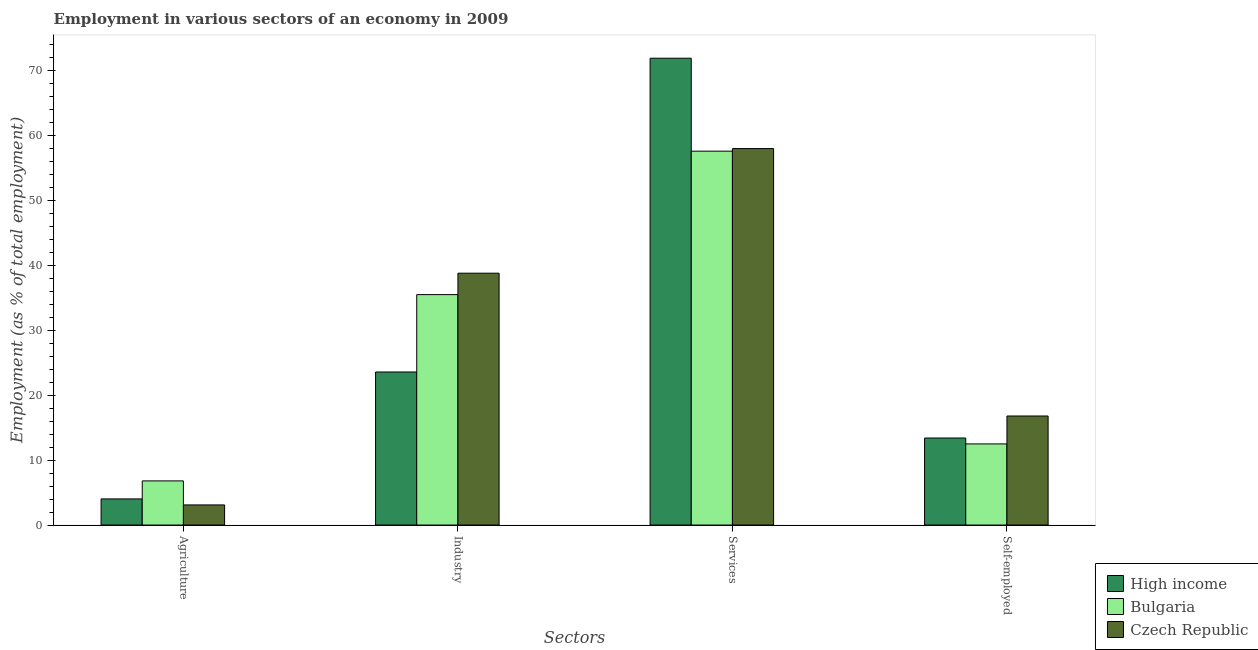How many different coloured bars are there?
Give a very brief answer. 3. How many bars are there on the 2nd tick from the left?
Keep it short and to the point. 3. How many bars are there on the 1st tick from the right?
Keep it short and to the point. 3. What is the label of the 1st group of bars from the left?
Offer a very short reply. Agriculture. What is the percentage of workers in agriculture in Czech Republic?
Offer a terse response. 3.1. Across all countries, what is the maximum percentage of workers in services?
Give a very brief answer. 71.92. Across all countries, what is the minimum percentage of workers in services?
Your answer should be very brief. 57.6. In which country was the percentage of workers in services maximum?
Make the answer very short. High income. In which country was the percentage of workers in industry minimum?
Your answer should be compact. High income. What is the total percentage of self employed workers in the graph?
Offer a terse response. 42.71. What is the difference between the percentage of self employed workers in Czech Republic and that in Bulgaria?
Provide a short and direct response. 4.3. What is the difference between the percentage of workers in agriculture in Bulgaria and the percentage of workers in services in Czech Republic?
Offer a terse response. -51.2. What is the average percentage of self employed workers per country?
Make the answer very short. 14.24. What is the difference between the percentage of workers in industry and percentage of workers in services in High income?
Provide a succinct answer. -48.34. What is the ratio of the percentage of workers in agriculture in High income to that in Bulgaria?
Provide a short and direct response. 0.59. Is the percentage of workers in services in High income less than that in Bulgaria?
Make the answer very short. No. What is the difference between the highest and the second highest percentage of workers in agriculture?
Make the answer very short. 2.77. What is the difference between the highest and the lowest percentage of self employed workers?
Make the answer very short. 4.3. What does the 3rd bar from the right in Services represents?
Keep it short and to the point. High income. Is it the case that in every country, the sum of the percentage of workers in agriculture and percentage of workers in industry is greater than the percentage of workers in services?
Provide a succinct answer. No. How many bars are there?
Offer a terse response. 12. Are the values on the major ticks of Y-axis written in scientific E-notation?
Provide a short and direct response. No. Does the graph contain any zero values?
Your answer should be very brief. No. How many legend labels are there?
Provide a short and direct response. 3. What is the title of the graph?
Offer a very short reply. Employment in various sectors of an economy in 2009. What is the label or title of the X-axis?
Your response must be concise. Sectors. What is the label or title of the Y-axis?
Offer a terse response. Employment (as % of total employment). What is the Employment (as % of total employment) of High income in Agriculture?
Your answer should be compact. 4.03. What is the Employment (as % of total employment) of Bulgaria in Agriculture?
Your answer should be very brief. 6.8. What is the Employment (as % of total employment) in Czech Republic in Agriculture?
Make the answer very short. 3.1. What is the Employment (as % of total employment) of High income in Industry?
Make the answer very short. 23.58. What is the Employment (as % of total employment) in Bulgaria in Industry?
Give a very brief answer. 35.5. What is the Employment (as % of total employment) in Czech Republic in Industry?
Provide a succinct answer. 38.8. What is the Employment (as % of total employment) of High income in Services?
Ensure brevity in your answer.  71.92. What is the Employment (as % of total employment) in Bulgaria in Services?
Make the answer very short. 57.6. What is the Employment (as % of total employment) in High income in Self-employed?
Provide a succinct answer. 13.41. What is the Employment (as % of total employment) of Bulgaria in Self-employed?
Give a very brief answer. 12.5. What is the Employment (as % of total employment) in Czech Republic in Self-employed?
Your response must be concise. 16.8. Across all Sectors, what is the maximum Employment (as % of total employment) of High income?
Offer a very short reply. 71.92. Across all Sectors, what is the maximum Employment (as % of total employment) in Bulgaria?
Your answer should be very brief. 57.6. Across all Sectors, what is the minimum Employment (as % of total employment) in High income?
Make the answer very short. 4.03. Across all Sectors, what is the minimum Employment (as % of total employment) of Bulgaria?
Give a very brief answer. 6.8. Across all Sectors, what is the minimum Employment (as % of total employment) in Czech Republic?
Your answer should be compact. 3.1. What is the total Employment (as % of total employment) of High income in the graph?
Keep it short and to the point. 112.93. What is the total Employment (as % of total employment) of Bulgaria in the graph?
Your response must be concise. 112.4. What is the total Employment (as % of total employment) of Czech Republic in the graph?
Provide a short and direct response. 116.7. What is the difference between the Employment (as % of total employment) of High income in Agriculture and that in Industry?
Your response must be concise. -19.55. What is the difference between the Employment (as % of total employment) of Bulgaria in Agriculture and that in Industry?
Keep it short and to the point. -28.7. What is the difference between the Employment (as % of total employment) in Czech Republic in Agriculture and that in Industry?
Your answer should be very brief. -35.7. What is the difference between the Employment (as % of total employment) in High income in Agriculture and that in Services?
Provide a succinct answer. -67.89. What is the difference between the Employment (as % of total employment) in Bulgaria in Agriculture and that in Services?
Offer a very short reply. -50.8. What is the difference between the Employment (as % of total employment) in Czech Republic in Agriculture and that in Services?
Ensure brevity in your answer.  -54.9. What is the difference between the Employment (as % of total employment) in High income in Agriculture and that in Self-employed?
Your answer should be compact. -9.38. What is the difference between the Employment (as % of total employment) in Bulgaria in Agriculture and that in Self-employed?
Your response must be concise. -5.7. What is the difference between the Employment (as % of total employment) of Czech Republic in Agriculture and that in Self-employed?
Provide a short and direct response. -13.7. What is the difference between the Employment (as % of total employment) in High income in Industry and that in Services?
Provide a short and direct response. -48.34. What is the difference between the Employment (as % of total employment) of Bulgaria in Industry and that in Services?
Give a very brief answer. -22.1. What is the difference between the Employment (as % of total employment) of Czech Republic in Industry and that in Services?
Make the answer very short. -19.2. What is the difference between the Employment (as % of total employment) in High income in Industry and that in Self-employed?
Make the answer very short. 10.17. What is the difference between the Employment (as % of total employment) in High income in Services and that in Self-employed?
Offer a terse response. 58.51. What is the difference between the Employment (as % of total employment) in Bulgaria in Services and that in Self-employed?
Your response must be concise. 45.1. What is the difference between the Employment (as % of total employment) in Czech Republic in Services and that in Self-employed?
Your response must be concise. 41.2. What is the difference between the Employment (as % of total employment) of High income in Agriculture and the Employment (as % of total employment) of Bulgaria in Industry?
Your answer should be compact. -31.47. What is the difference between the Employment (as % of total employment) of High income in Agriculture and the Employment (as % of total employment) of Czech Republic in Industry?
Your answer should be compact. -34.77. What is the difference between the Employment (as % of total employment) in Bulgaria in Agriculture and the Employment (as % of total employment) in Czech Republic in Industry?
Your response must be concise. -32. What is the difference between the Employment (as % of total employment) in High income in Agriculture and the Employment (as % of total employment) in Bulgaria in Services?
Your answer should be compact. -53.57. What is the difference between the Employment (as % of total employment) of High income in Agriculture and the Employment (as % of total employment) of Czech Republic in Services?
Provide a short and direct response. -53.97. What is the difference between the Employment (as % of total employment) of Bulgaria in Agriculture and the Employment (as % of total employment) of Czech Republic in Services?
Ensure brevity in your answer.  -51.2. What is the difference between the Employment (as % of total employment) in High income in Agriculture and the Employment (as % of total employment) in Bulgaria in Self-employed?
Offer a very short reply. -8.47. What is the difference between the Employment (as % of total employment) in High income in Agriculture and the Employment (as % of total employment) in Czech Republic in Self-employed?
Ensure brevity in your answer.  -12.77. What is the difference between the Employment (as % of total employment) in High income in Industry and the Employment (as % of total employment) in Bulgaria in Services?
Your answer should be very brief. -34.02. What is the difference between the Employment (as % of total employment) in High income in Industry and the Employment (as % of total employment) in Czech Republic in Services?
Make the answer very short. -34.42. What is the difference between the Employment (as % of total employment) of Bulgaria in Industry and the Employment (as % of total employment) of Czech Republic in Services?
Your response must be concise. -22.5. What is the difference between the Employment (as % of total employment) of High income in Industry and the Employment (as % of total employment) of Bulgaria in Self-employed?
Keep it short and to the point. 11.08. What is the difference between the Employment (as % of total employment) of High income in Industry and the Employment (as % of total employment) of Czech Republic in Self-employed?
Make the answer very short. 6.78. What is the difference between the Employment (as % of total employment) in Bulgaria in Industry and the Employment (as % of total employment) in Czech Republic in Self-employed?
Ensure brevity in your answer.  18.7. What is the difference between the Employment (as % of total employment) of High income in Services and the Employment (as % of total employment) of Bulgaria in Self-employed?
Make the answer very short. 59.42. What is the difference between the Employment (as % of total employment) of High income in Services and the Employment (as % of total employment) of Czech Republic in Self-employed?
Offer a terse response. 55.12. What is the difference between the Employment (as % of total employment) of Bulgaria in Services and the Employment (as % of total employment) of Czech Republic in Self-employed?
Offer a terse response. 40.8. What is the average Employment (as % of total employment) of High income per Sectors?
Your answer should be compact. 28.23. What is the average Employment (as % of total employment) in Bulgaria per Sectors?
Make the answer very short. 28.1. What is the average Employment (as % of total employment) of Czech Republic per Sectors?
Offer a very short reply. 29.18. What is the difference between the Employment (as % of total employment) of High income and Employment (as % of total employment) of Bulgaria in Agriculture?
Ensure brevity in your answer.  -2.77. What is the difference between the Employment (as % of total employment) in High income and Employment (as % of total employment) in Czech Republic in Agriculture?
Your response must be concise. 0.93. What is the difference between the Employment (as % of total employment) in High income and Employment (as % of total employment) in Bulgaria in Industry?
Provide a short and direct response. -11.92. What is the difference between the Employment (as % of total employment) of High income and Employment (as % of total employment) of Czech Republic in Industry?
Offer a very short reply. -15.22. What is the difference between the Employment (as % of total employment) in High income and Employment (as % of total employment) in Bulgaria in Services?
Offer a very short reply. 14.32. What is the difference between the Employment (as % of total employment) of High income and Employment (as % of total employment) of Czech Republic in Services?
Give a very brief answer. 13.92. What is the difference between the Employment (as % of total employment) of Bulgaria and Employment (as % of total employment) of Czech Republic in Services?
Offer a very short reply. -0.4. What is the difference between the Employment (as % of total employment) in High income and Employment (as % of total employment) in Bulgaria in Self-employed?
Provide a short and direct response. 0.91. What is the difference between the Employment (as % of total employment) of High income and Employment (as % of total employment) of Czech Republic in Self-employed?
Offer a very short reply. -3.39. What is the difference between the Employment (as % of total employment) of Bulgaria and Employment (as % of total employment) of Czech Republic in Self-employed?
Give a very brief answer. -4.3. What is the ratio of the Employment (as % of total employment) in High income in Agriculture to that in Industry?
Ensure brevity in your answer.  0.17. What is the ratio of the Employment (as % of total employment) in Bulgaria in Agriculture to that in Industry?
Your answer should be very brief. 0.19. What is the ratio of the Employment (as % of total employment) of Czech Republic in Agriculture to that in Industry?
Make the answer very short. 0.08. What is the ratio of the Employment (as % of total employment) in High income in Agriculture to that in Services?
Ensure brevity in your answer.  0.06. What is the ratio of the Employment (as % of total employment) of Bulgaria in Agriculture to that in Services?
Your answer should be very brief. 0.12. What is the ratio of the Employment (as % of total employment) of Czech Republic in Agriculture to that in Services?
Offer a terse response. 0.05. What is the ratio of the Employment (as % of total employment) of High income in Agriculture to that in Self-employed?
Ensure brevity in your answer.  0.3. What is the ratio of the Employment (as % of total employment) of Bulgaria in Agriculture to that in Self-employed?
Provide a succinct answer. 0.54. What is the ratio of the Employment (as % of total employment) of Czech Republic in Agriculture to that in Self-employed?
Provide a succinct answer. 0.18. What is the ratio of the Employment (as % of total employment) in High income in Industry to that in Services?
Provide a short and direct response. 0.33. What is the ratio of the Employment (as % of total employment) of Bulgaria in Industry to that in Services?
Keep it short and to the point. 0.62. What is the ratio of the Employment (as % of total employment) of Czech Republic in Industry to that in Services?
Offer a very short reply. 0.67. What is the ratio of the Employment (as % of total employment) of High income in Industry to that in Self-employed?
Your response must be concise. 1.76. What is the ratio of the Employment (as % of total employment) of Bulgaria in Industry to that in Self-employed?
Your answer should be very brief. 2.84. What is the ratio of the Employment (as % of total employment) of Czech Republic in Industry to that in Self-employed?
Ensure brevity in your answer.  2.31. What is the ratio of the Employment (as % of total employment) in High income in Services to that in Self-employed?
Your response must be concise. 5.36. What is the ratio of the Employment (as % of total employment) of Bulgaria in Services to that in Self-employed?
Give a very brief answer. 4.61. What is the ratio of the Employment (as % of total employment) of Czech Republic in Services to that in Self-employed?
Ensure brevity in your answer.  3.45. What is the difference between the highest and the second highest Employment (as % of total employment) in High income?
Your answer should be compact. 48.34. What is the difference between the highest and the second highest Employment (as % of total employment) in Bulgaria?
Ensure brevity in your answer.  22.1. What is the difference between the highest and the second highest Employment (as % of total employment) of Czech Republic?
Ensure brevity in your answer.  19.2. What is the difference between the highest and the lowest Employment (as % of total employment) of High income?
Keep it short and to the point. 67.89. What is the difference between the highest and the lowest Employment (as % of total employment) in Bulgaria?
Your answer should be compact. 50.8. What is the difference between the highest and the lowest Employment (as % of total employment) of Czech Republic?
Your answer should be compact. 54.9. 